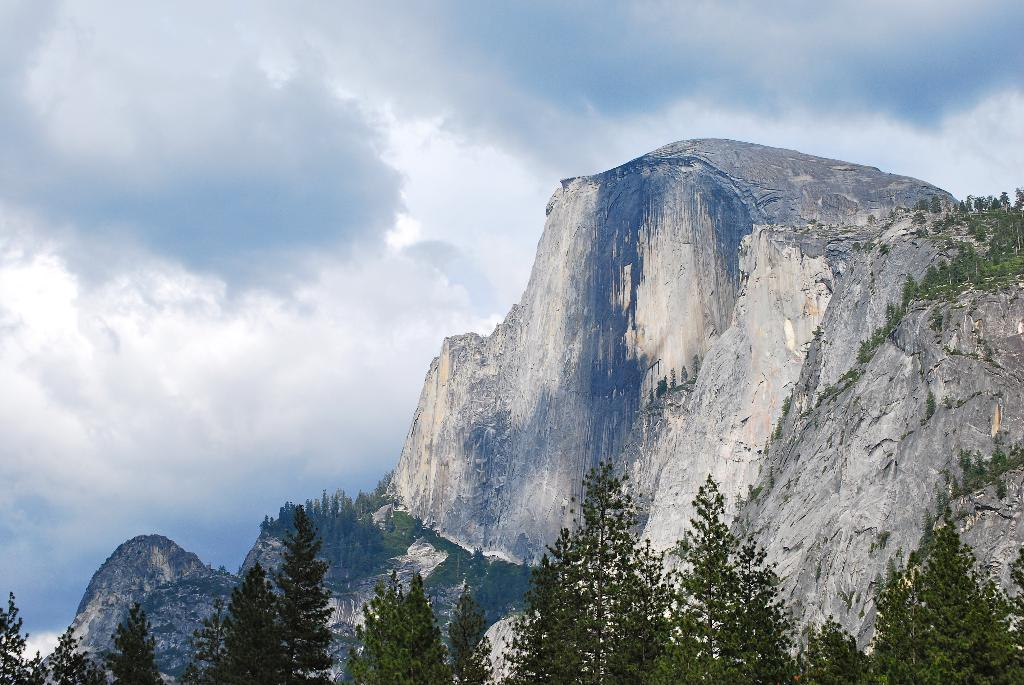What type of vegetation is at the bottom of the image? There are trees at the bottom of the image. What type of geographical feature is visible in the background of the image? There is a mountain in the background of the image. What is visible at the top of the image? The sky is visible at the top of the image. Can you see a zephyr blowing through the trees in the image? There is no mention of a zephyr in the image, and it is not visible. What type of lip can be seen on the mountain in the image? There is no lip present on the mountain in the image. 